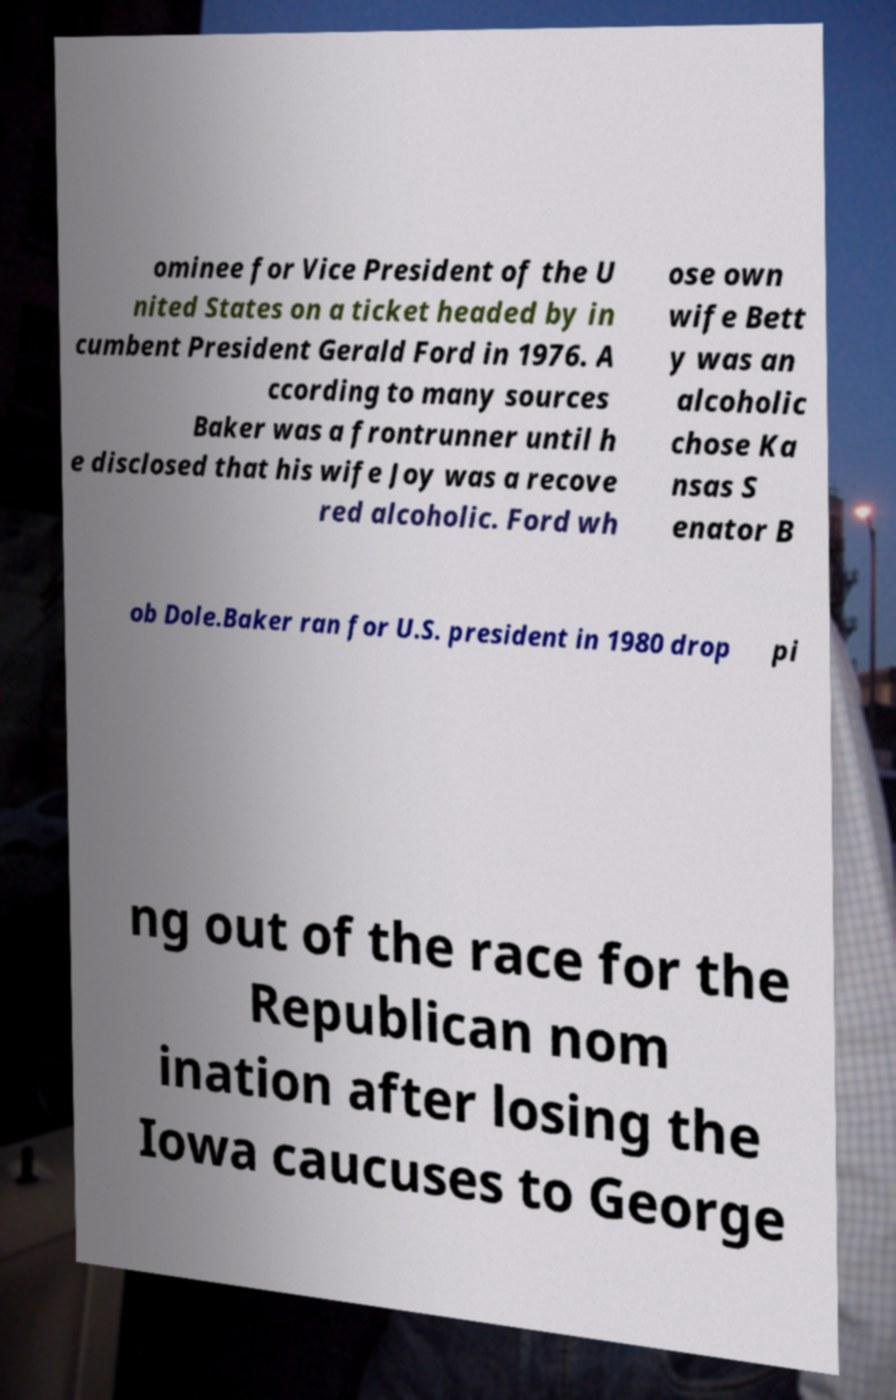Can you read and provide the text displayed in the image?This photo seems to have some interesting text. Can you extract and type it out for me? ominee for Vice President of the U nited States on a ticket headed by in cumbent President Gerald Ford in 1976. A ccording to many sources Baker was a frontrunner until h e disclosed that his wife Joy was a recove red alcoholic. Ford wh ose own wife Bett y was an alcoholic chose Ka nsas S enator B ob Dole.Baker ran for U.S. president in 1980 drop pi ng out of the race for the Republican nom ination after losing the Iowa caucuses to George 